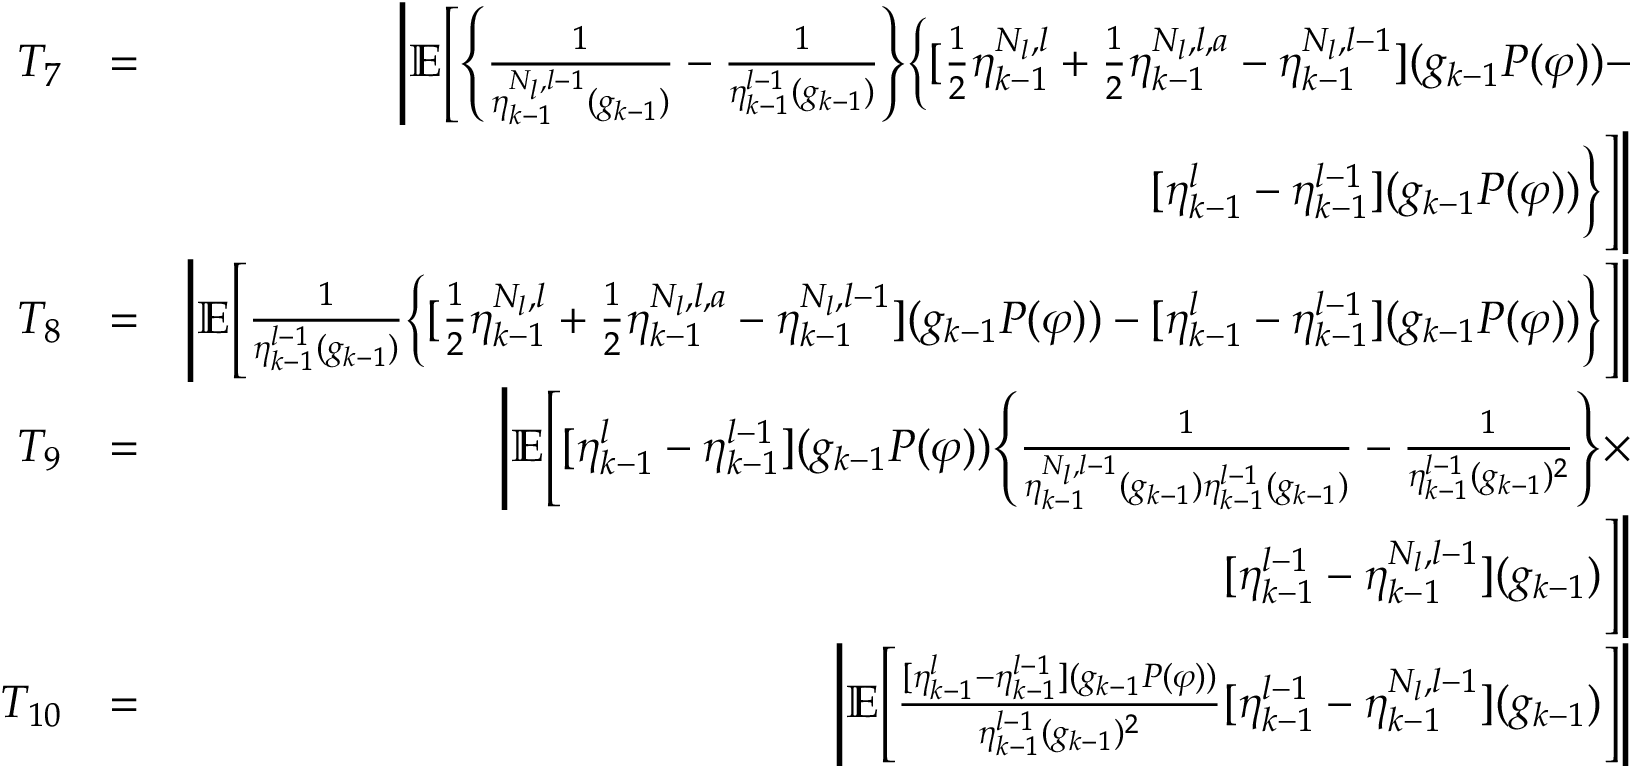Convert formula to latex. <formula><loc_0><loc_0><loc_500><loc_500>\begin{array} { r l r } { T _ { 7 } } & { = } & { \left | \mathbb { E } \left [ \left \{ \frac { 1 } { \eta _ { k - 1 } ^ { N _ { l } , l - 1 } ( g _ { k - 1 } ) } - \frac { 1 } { \eta _ { k - 1 } ^ { l - 1 } ( g _ { k - 1 } ) } \right \} \left \{ [ \frac { 1 } { 2 } \eta _ { k - 1 } ^ { N _ { l } , l } + \frac { 1 } { 2 } \eta _ { k - 1 } ^ { N _ { l } , l , a } - \eta _ { k - 1 } ^ { N _ { l } , l - 1 } ] ( g _ { k - 1 } P ( \varphi ) ) - } \\ & { [ \eta _ { k - 1 } ^ { l } - \eta _ { k - 1 } ^ { l - 1 } ] ( g _ { k - 1 } P ( \varphi ) ) \right \} \right ] \right | } \\ { T _ { 8 } } & { = } & { \left | \mathbb { E } \left [ \frac { 1 } { \eta _ { k - 1 } ^ { l - 1 } ( g _ { k - 1 } ) } \left \{ [ \frac { 1 } { 2 } \eta _ { k - 1 } ^ { N _ { l } , l } + \frac { 1 } { 2 } \eta _ { k - 1 } ^ { N _ { l } , l , a } - \eta _ { k - 1 } ^ { N _ { l } , l - 1 } ] ( g _ { k - 1 } P ( \varphi ) ) - [ \eta _ { k - 1 } ^ { l } - \eta _ { k - 1 } ^ { l - 1 } ] ( g _ { k - 1 } P ( \varphi ) ) \right \} \right ] \right | } \\ { T _ { 9 } } & { = } & { \left | \mathbb { E } \left [ [ \eta _ { k - 1 } ^ { l } - \eta _ { k - 1 } ^ { l - 1 } ] ( g _ { k - 1 } P ( \varphi ) ) \left \{ \frac { 1 } { \eta _ { k - 1 } ^ { N _ { l } , l - 1 } ( g _ { k - 1 } ) \eta _ { k - 1 } ^ { l - 1 } ( g _ { k - 1 } ) } - \frac { 1 } { \eta _ { k - 1 } ^ { l - 1 } ( g _ { k - 1 } ) ^ { 2 } } \right \} \times } \\ & { [ \eta _ { k - 1 } ^ { l - 1 } - \eta _ { k - 1 } ^ { N _ { l } , l - 1 } ] ( g _ { k - 1 } ) \right ] \right | } \\ { T _ { 1 0 } } & { = } & { \left | \mathbb { E } \left [ \frac { [ \eta _ { k - 1 } ^ { l } - \eta _ { k - 1 } ^ { l - 1 } ] ( g _ { k - 1 } P ( \varphi ) ) } { \eta _ { k - 1 } ^ { l - 1 } ( g _ { k - 1 } ) ^ { 2 } } [ \eta _ { k - 1 } ^ { l - 1 } - \eta _ { k - 1 } ^ { N _ { l } , l - 1 } ] ( g _ { k - 1 } ) \right ] \right | } \end{array}</formula> 